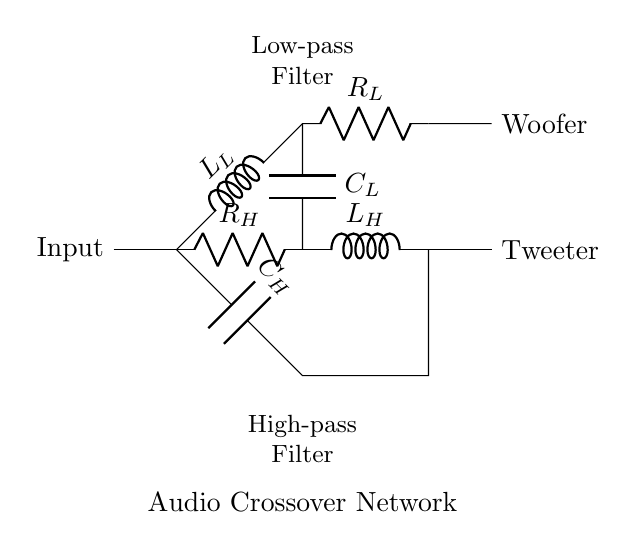What components are used in this audio crossover network? The circuit includes a resistor, an inductor, and a capacitor, specifically labeled as R_H, L_H, C_H, L_L, R_L, and C_L.
Answer: Resistor, Inductor, Capacitor What is the function of the high-pass filter in this circuit? The high-pass filter allows signals with frequencies higher than a certain cutoff frequency to pass through while attenuating lower frequencies. It is represented by the components R_H, L_H, and C_H in the diagram.
Answer: High-pass filtering Which output is designated for the woofer? The output for the woofer is connected to the high side of the low-pass filter, represented by the connection to node 5,2.
Answer: Woofer How many filters are present in this audio crossover network? There are two filters present: a high-pass filter and a low-pass filter, each consisting of specific RLC components.
Answer: Two filters What role does the capacitor C_H play in the circuit? Capacitor C_H in the high-pass filter blocks DC signals and allows AC signals above its cutoff frequency to pass through, helping in directing the high-frequency sound to the tweeter.
Answer: Coupling high frequencies What is the relationship between the inductor L_L and the low-pass filter? Inductor L_L is part of the low-pass filter, where it works in conjunction with the resistor R_L and capacitor C_L to allow signals with lower frequencies to pass through while blocking higher frequencies.
Answer: Low-pass filtering 